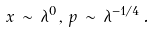<formula> <loc_0><loc_0><loc_500><loc_500>x \, \sim \, \lambda ^ { 0 } \, , \, p \, \sim \, \lambda ^ { - 1 / 4 } \, .</formula> 